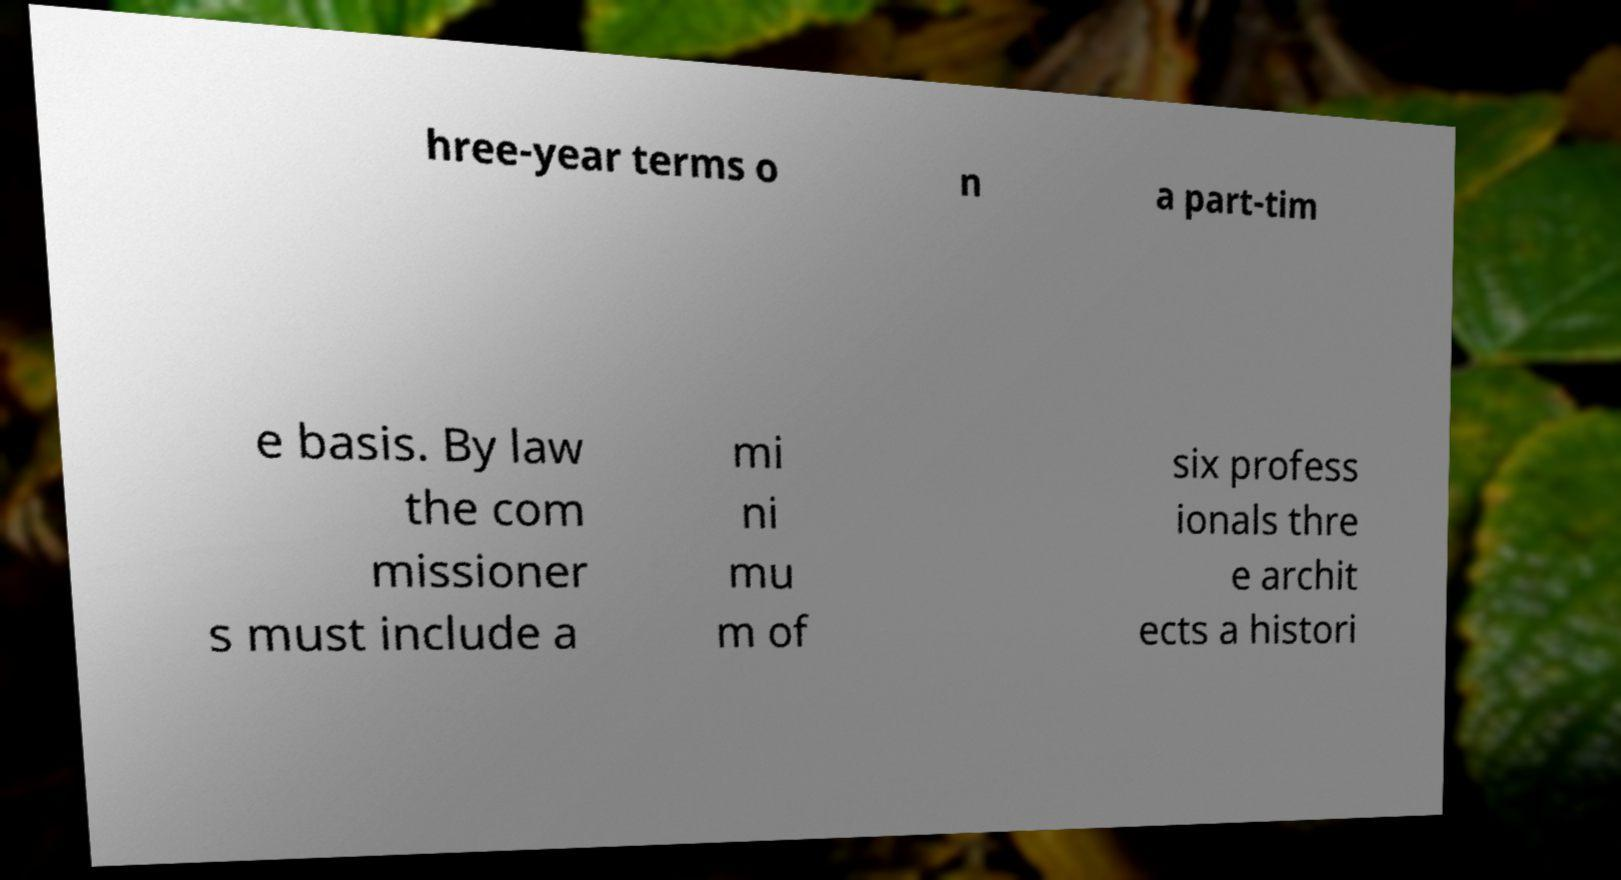There's text embedded in this image that I need extracted. Can you transcribe it verbatim? hree-year terms o n a part-tim e basis. By law the com missioner s must include a mi ni mu m of six profess ionals thre e archit ects a histori 